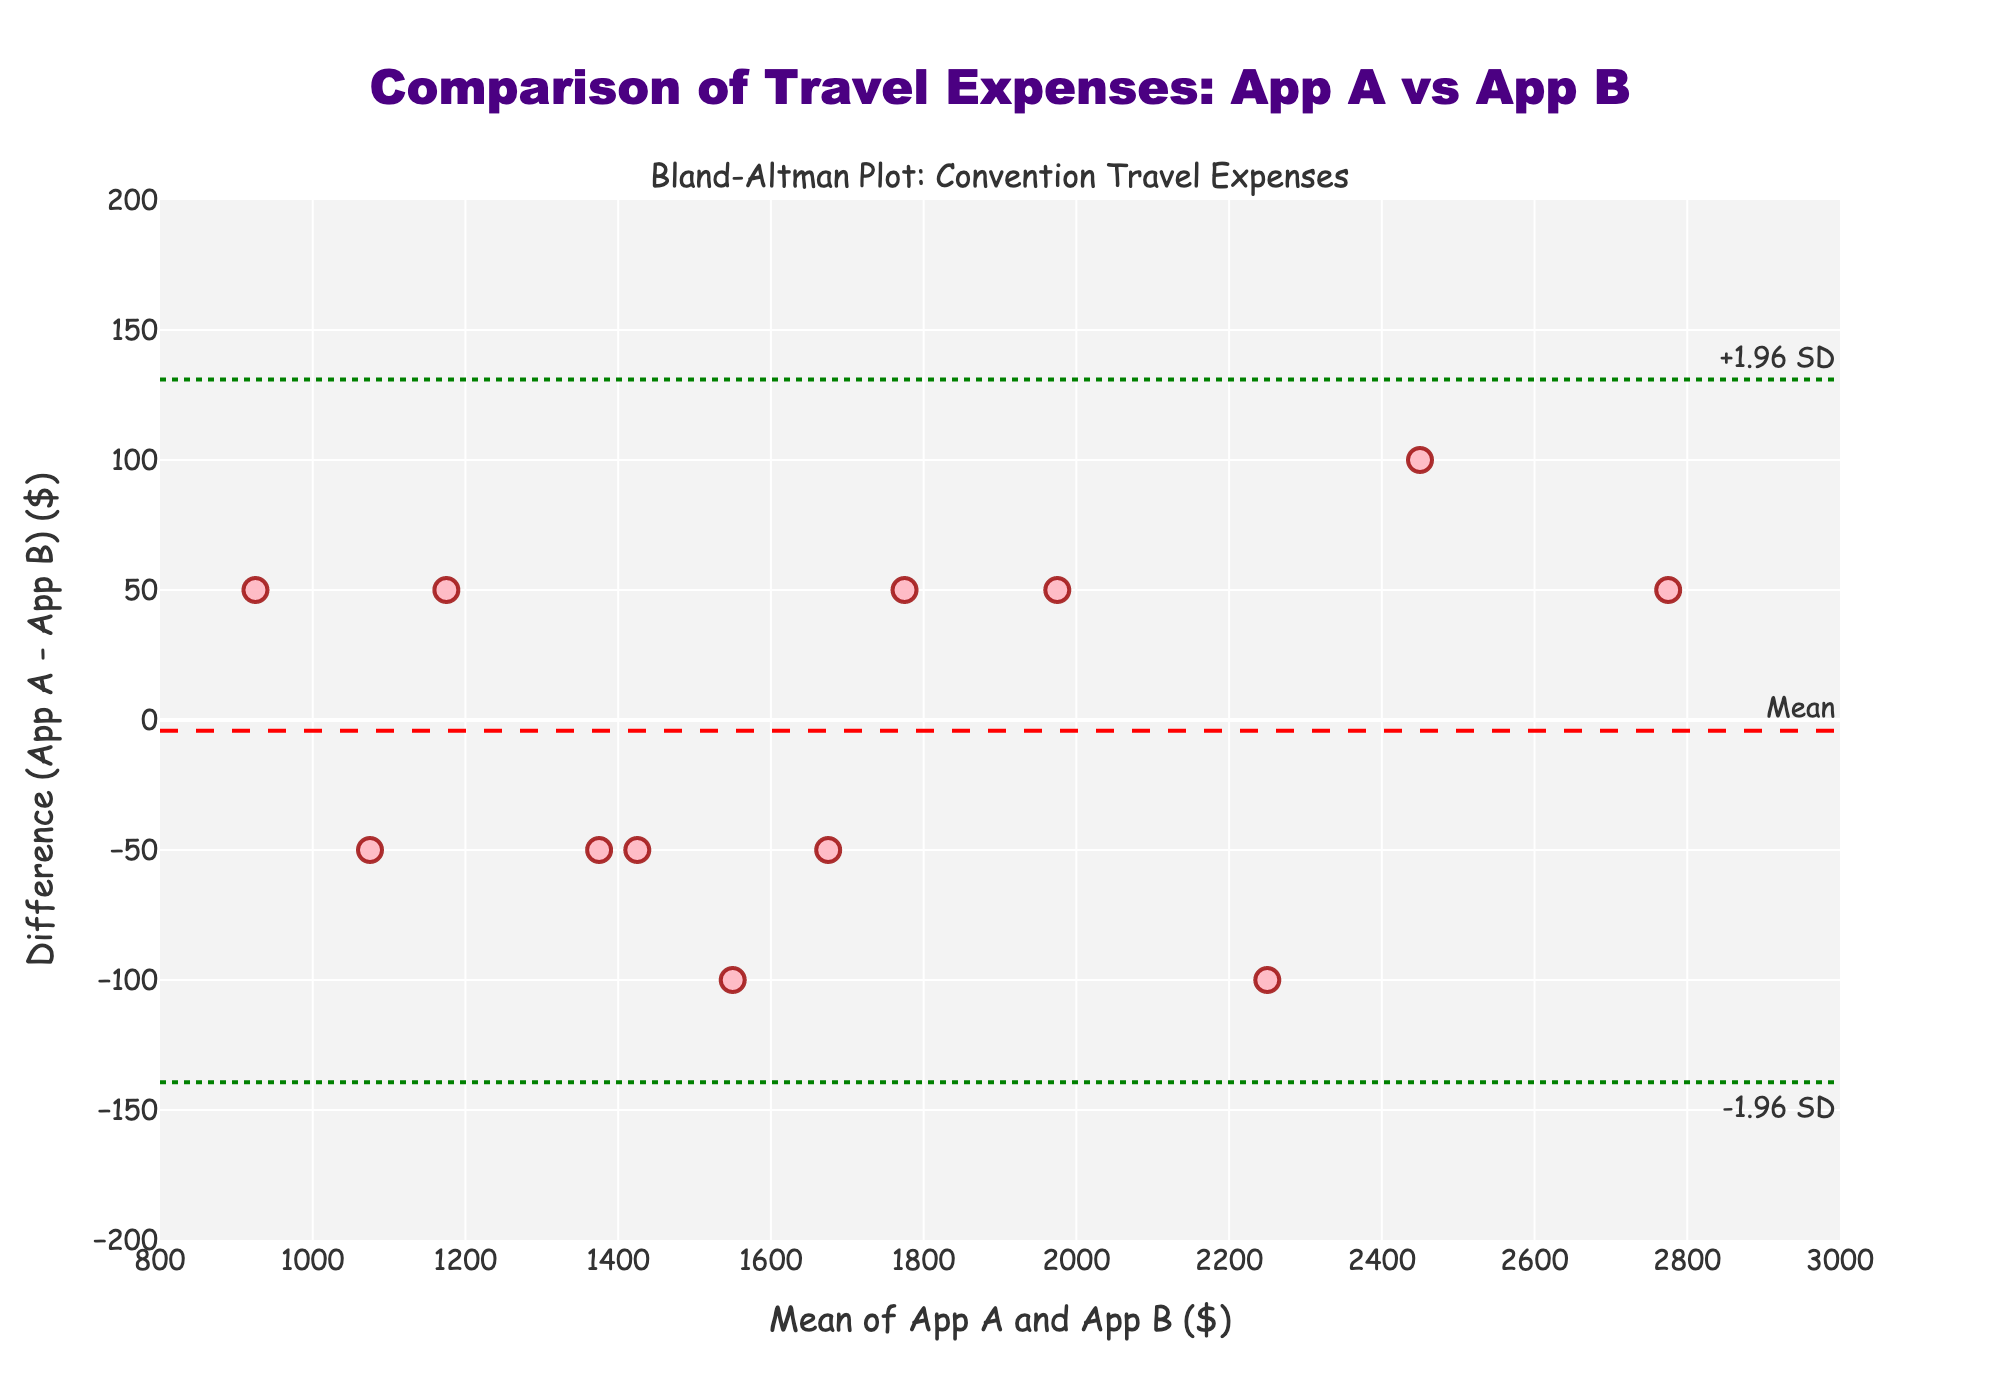What is the title of the figure? The title of the figure is typically displayed at the top and summarizes what the plot represents. In this case, it reads "Comparison of Travel Expenses: App A vs App B."
Answer: Comparison of Travel Expenses: App A vs App B What is the x-axis representing in this plot? The label along the x-axis indicates that it represents the "Mean of App A and App B ($)," which is the average travel expense estimated by both apps.
Answer: Mean of App A and App B ($) What colors are used to represent the data points and the lines in the plot? The data points are shown in a pink color with red outlines, and the lines representing the mean difference and limits of agreement are dashed red and dotted green, respectively.
Answer: Pink (data points), red (mean difference line), green (limits of agreement lines) How many data points are plotted in the Bland-Altman plot? To find the number of data points, count the number of markers shown in the scatter plot. There are 12 markers, corresponding to 12 data points.
Answer: 12 What is the range of the y-axis in the plot? The y-axis range denotes the difference in travel expenses estimated by the two budgeting apps. It spans from -200 to 200 dollars, as indicated by the tick marks.
Answer: -200 to 200 What mathematical operation is used to calculate the values on the x-axis? The x-axis values are computed by averaging the expenses estimated by Budgeting App A and Budgeting App B. This involves summing the two values and dividing by 2.
Answer: Averaging Is there any data point that lies exactly on the mean difference line? A data point lies on the mean difference line if its y-value (difference) equals the mean difference. Observing the plot, there is no data point that lies exactly on this red dashed line.
Answer: No What are the upper and lower limits of agreement in the plot? The upper and lower limits of agreement are calculated as the mean difference plus and minus 1.96 times the standard deviation of the differences. These values are displayed near the dotted green lines.
Answer: +100, -100 Do any data points fall outside the limits of agreement? Look at the data points in relation to the dotted green lines. If any points are outside these lines, they fall outside the limits of agreement. In this plot, no points fall outside these boundaries.
Answer: No Which budgeting app generally estimates higher travel expenses, based on the plot? If most of the differences are positive (above the mean line), Budgeting App A estimates higher values. Conversely, if the differences are generally negative, Budgeting App B estimates higher. Here, most differences are spread close to zero with fewer outliers showing a small bias.
Answer: Neither significantly higher 